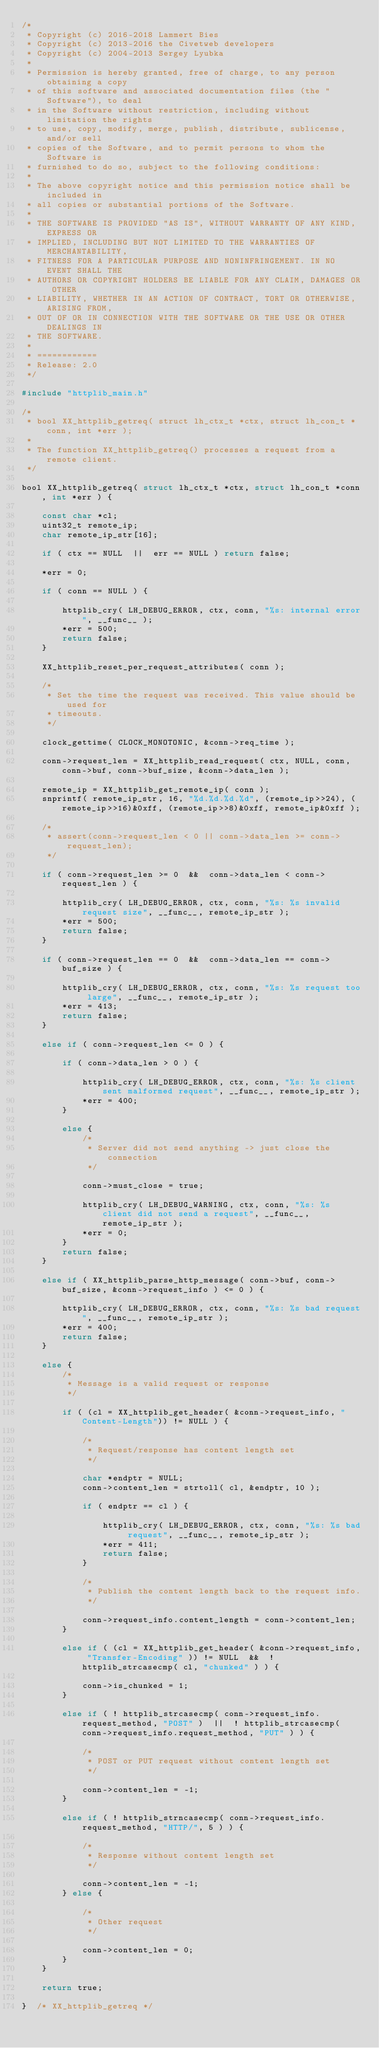Convert code to text. <code><loc_0><loc_0><loc_500><loc_500><_C_>/* 
 * Copyright (c) 2016-2018 Lammert Bies
 * Copyright (c) 2013-2016 the Civetweb developers
 * Copyright (c) 2004-2013 Sergey Lyubka
 *
 * Permission is hereby granted, free of charge, to any person obtaining a copy
 * of this software and associated documentation files (the "Software"), to deal
 * in the Software without restriction, including without limitation the rights
 * to use, copy, modify, merge, publish, distribute, sublicense, and/or sell
 * copies of the Software, and to permit persons to whom the Software is
 * furnished to do so, subject to the following conditions:
 *
 * The above copyright notice and this permission notice shall be included in
 * all copies or substantial portions of the Software.
 *
 * THE SOFTWARE IS PROVIDED "AS IS", WITHOUT WARRANTY OF ANY KIND, EXPRESS OR
 * IMPLIED, INCLUDING BUT NOT LIMITED TO THE WARRANTIES OF MERCHANTABILITY,
 * FITNESS FOR A PARTICULAR PURPOSE AND NONINFRINGEMENT. IN NO EVENT SHALL THE
 * AUTHORS OR COPYRIGHT HOLDERS BE LIABLE FOR ANY CLAIM, DAMAGES OR OTHER
 * LIABILITY, WHETHER IN AN ACTION OF CONTRACT, TORT OR OTHERWISE, ARISING FROM,
 * OUT OF OR IN CONNECTION WITH THE SOFTWARE OR THE USE OR OTHER DEALINGS IN
 * THE SOFTWARE.
 *
 * ============
 * Release: 2.0
 */

#include "httplib_main.h"

/*
 * bool XX_httplib_getreq( struct lh_ctx_t *ctx, struct lh_con_t *conn, int *err );
 *
 * The function XX_httplib_getreq() processes a request from a remote client.
 */

bool XX_httplib_getreq( struct lh_ctx_t *ctx, struct lh_con_t *conn, int *err ) {

	const char *cl;
	uint32_t remote_ip;
	char remote_ip_str[16];

	if ( ctx == NULL  ||  err == NULL ) return false;

	*err = 0;

	if ( conn == NULL ) {

		httplib_cry( LH_DEBUG_ERROR, ctx, conn, "%s: internal error", __func__ );
		*err = 500;
		return false;
	}

	XX_httplib_reset_per_request_attributes( conn );

	/*
	 * Set the time the request was received. This value should be used for
	 * timeouts.
	 */

	clock_gettime( CLOCK_MONOTONIC, &conn->req_time );

	conn->request_len = XX_httplib_read_request( ctx, NULL, conn, conn->buf, conn->buf_size, &conn->data_len );

	remote_ip = XX_httplib_get_remote_ip( conn );
	snprintf( remote_ip_str, 16, "%d.%d.%d.%d", (remote_ip>>24), (remote_ip>>16)&0xff, (remote_ip>>8)&0xff, remote_ip&0xff );

	/* 
	 * assert(conn->request_len < 0 || conn->data_len >= conn->request_len);
	 */

	if ( conn->request_len >= 0  &&  conn->data_len < conn->request_len ) {

		httplib_cry( LH_DEBUG_ERROR, ctx, conn, "%s: %s invalid request size", __func__, remote_ip_str );
		*err = 500;
		return false;
	}

	if ( conn->request_len == 0  &&  conn->data_len == conn->buf_size ) {

		httplib_cry( LH_DEBUG_ERROR, ctx, conn, "%s: %s request too large", __func__, remote_ip_str );
		*err = 413;
		return false;
	}
	
	else if ( conn->request_len <= 0 ) {

		if ( conn->data_len > 0 ) {

			httplib_cry( LH_DEBUG_ERROR, ctx, conn, "%s: %s client sent malformed request", __func__, remote_ip_str );
			*err = 400;
		}
		
		else {
			/*
			 * Server did not send anything -> just close the connection
			 */

			conn->must_close = true;

			httplib_cry( LH_DEBUG_WARNING, ctx, conn, "%s: %s client did not send a request", __func__, remote_ip_str );
			*err = 0;
		}
		return false;
	}
	
	else if ( XX_httplib_parse_http_message( conn->buf, conn->buf_size, &conn->request_info ) <= 0 ) {

		httplib_cry( LH_DEBUG_ERROR, ctx, conn, "%s: %s bad request", __func__, remote_ip_str );
		*err = 400;
		return false;
	}
	
	else {
		/*
		 * Message is a valid request or response
		 */

		if ( (cl = XX_httplib_get_header( &conn->request_info, "Content-Length")) != NULL ) {

			/*
			 * Request/response has content length set
			 */

			char *endptr = NULL;
			conn->content_len = strtoll( cl, &endptr, 10 );

			if ( endptr == cl ) {

				httplib_cry( LH_DEBUG_ERROR, ctx, conn, "%s: %s bad request", __func__, remote_ip_str );
				*err = 411;
				return false;
			}

			/*
			 * Publish the content length back to the request info.
			 */

			conn->request_info.content_length = conn->content_len;
		}
		
		else if ( (cl = XX_httplib_get_header( &conn->request_info, "Transfer-Encoding" )) != NULL  &&  ! httplib_strcasecmp( cl, "chunked" ) ) {

			conn->is_chunked = 1;
		}
		
		else if ( ! httplib_strcasecmp( conn->request_info.request_method, "POST" )  ||  ! httplib_strcasecmp( conn->request_info.request_method, "PUT" ) ) {

			/*
			 * POST or PUT request without content length set
			 */

			conn->content_len = -1;
		}
		
		else if ( ! httplib_strncasecmp( conn->request_info.request_method, "HTTP/", 5 ) ) {

			/*
			 * Response without content length set
			 */

			conn->content_len = -1;
		} else {

			/*
			 * Other request
			 */

			conn->content_len = 0;
		}
	}

	return true;

}  /* XX_httplib_getreq */
</code> 